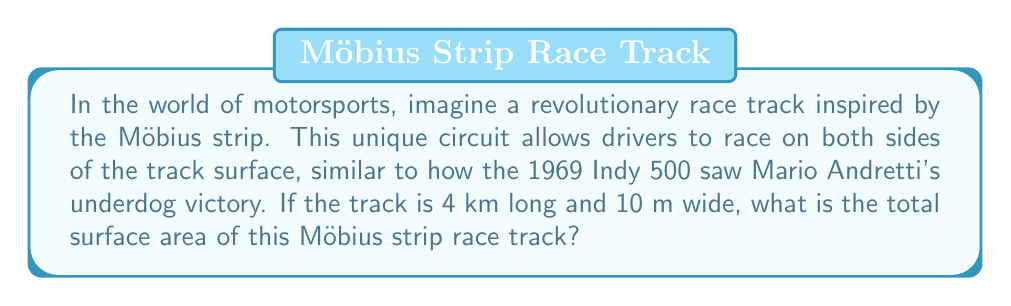Help me with this question. To solve this problem, we need to understand the properties of a Möbius strip and apply the formula for its surface area. Let's break it down step-by-step:

1. Recall that a Möbius strip is a surface with only one side and one edge. It's created by taking a long rectangle and giving it a half-twist before joining the ends.

2. The formula for the surface area of a Möbius strip is:

   $$A = \frac{1}{2}lw$$

   Where $l$ is the length of the strip and $w$ is the width.

3. In our case:
   $l = 4$ km $= 4000$ m
   $w = 10$ m

4. Plugging these values into the formula:

   $$A = \frac{1}{2} \times 4000 \text{ m} \times 10 \text{ m}$$

5. Simplifying:

   $$A = 20,000 \text{ m}^2$$

This result might seem counterintuitive at first, as it's half of what we'd expect for a regular rectangular track. This is because the Möbius strip effectively allows racers to cover both "sides" of the track in one lap, much like how a strategic pit stop can give a driver an unexpected advantage in a race.

[asy]
import geometry;

size(200);
pair A=(0,0), B=(4,0), C=(4,1), D=(0,1);
path p=A--B--C--D--cycle;
fill(p,lightgray);
draw(p);
label("4 km",B,S);
label("10 m",C,E);
draw((2,0)--(2,1),dashed);
label("Twist and connect",(-0.5,0.5),W);
[/asy]
Answer: The total surface area of the Möbius strip race track is 20,000 square meters. 